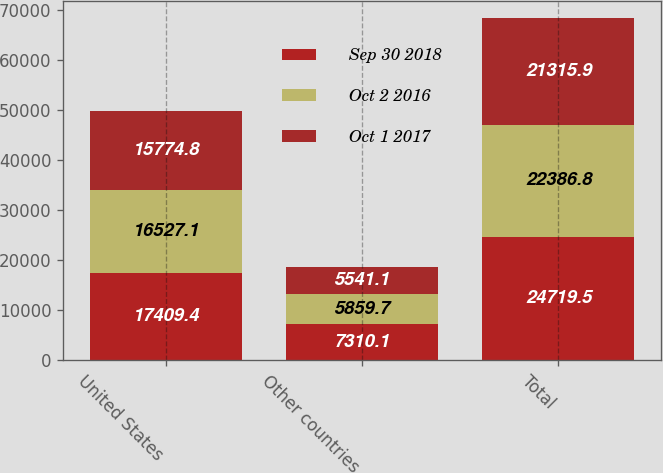Convert chart to OTSL. <chart><loc_0><loc_0><loc_500><loc_500><stacked_bar_chart><ecel><fcel>United States<fcel>Other countries<fcel>Total<nl><fcel>Sep 30 2018<fcel>17409.4<fcel>7310.1<fcel>24719.5<nl><fcel>Oct 2 2016<fcel>16527.1<fcel>5859.7<fcel>22386.8<nl><fcel>Oct 1 2017<fcel>15774.8<fcel>5541.1<fcel>21315.9<nl></chart> 